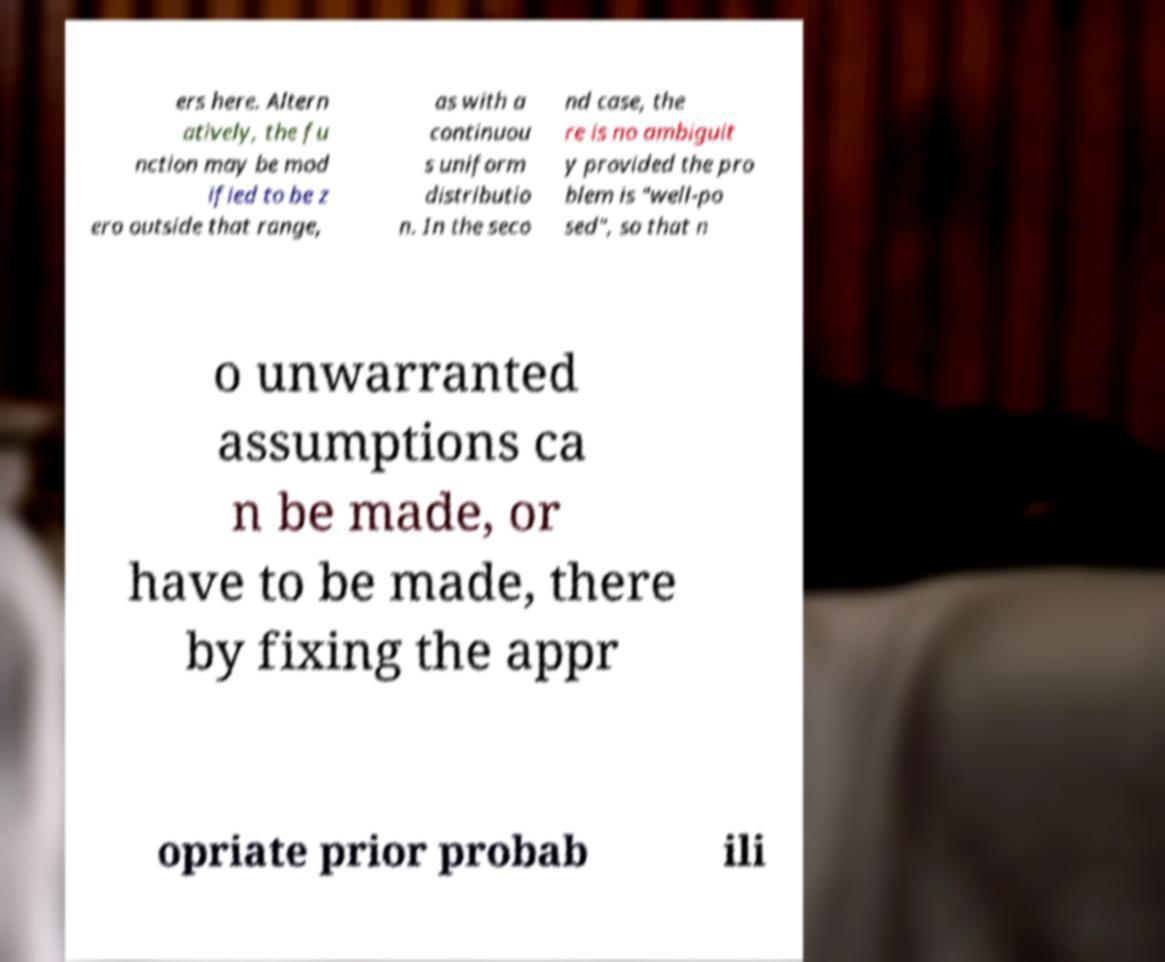Please identify and transcribe the text found in this image. ers here. Altern atively, the fu nction may be mod ified to be z ero outside that range, as with a continuou s uniform distributio n. In the seco nd case, the re is no ambiguit y provided the pro blem is "well-po sed", so that n o unwarranted assumptions ca n be made, or have to be made, there by fixing the appr opriate prior probab ili 